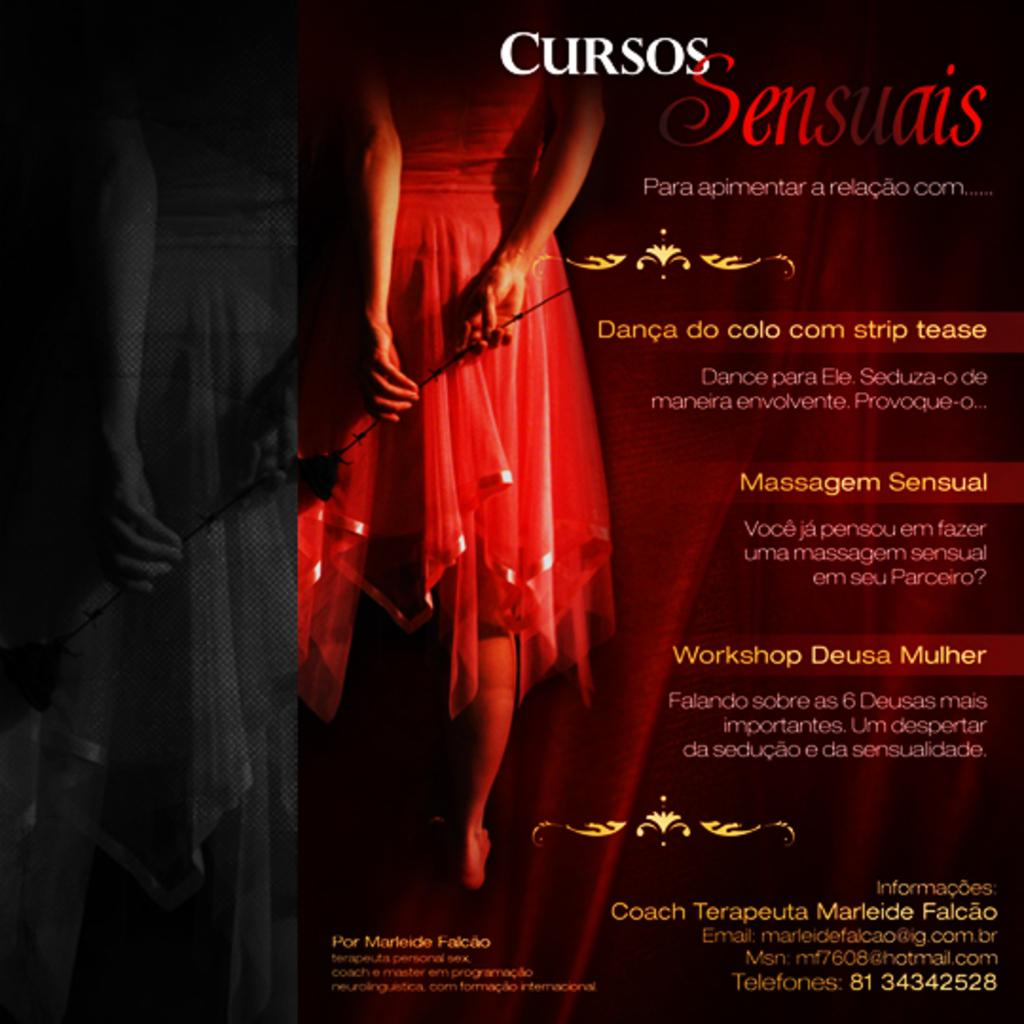Who is the main subject in the image? There is a girl in the image. What is the girl holding in the image? The girl is holding a flower. What else can be seen on the right side of the image? There is text on the right side of the image. What type of roof can be seen in the image? There is no roof present in the image. What act is the girl performing with the fork in the image? There is no fork present in the image, and the girl is not performing any act with a fork. 